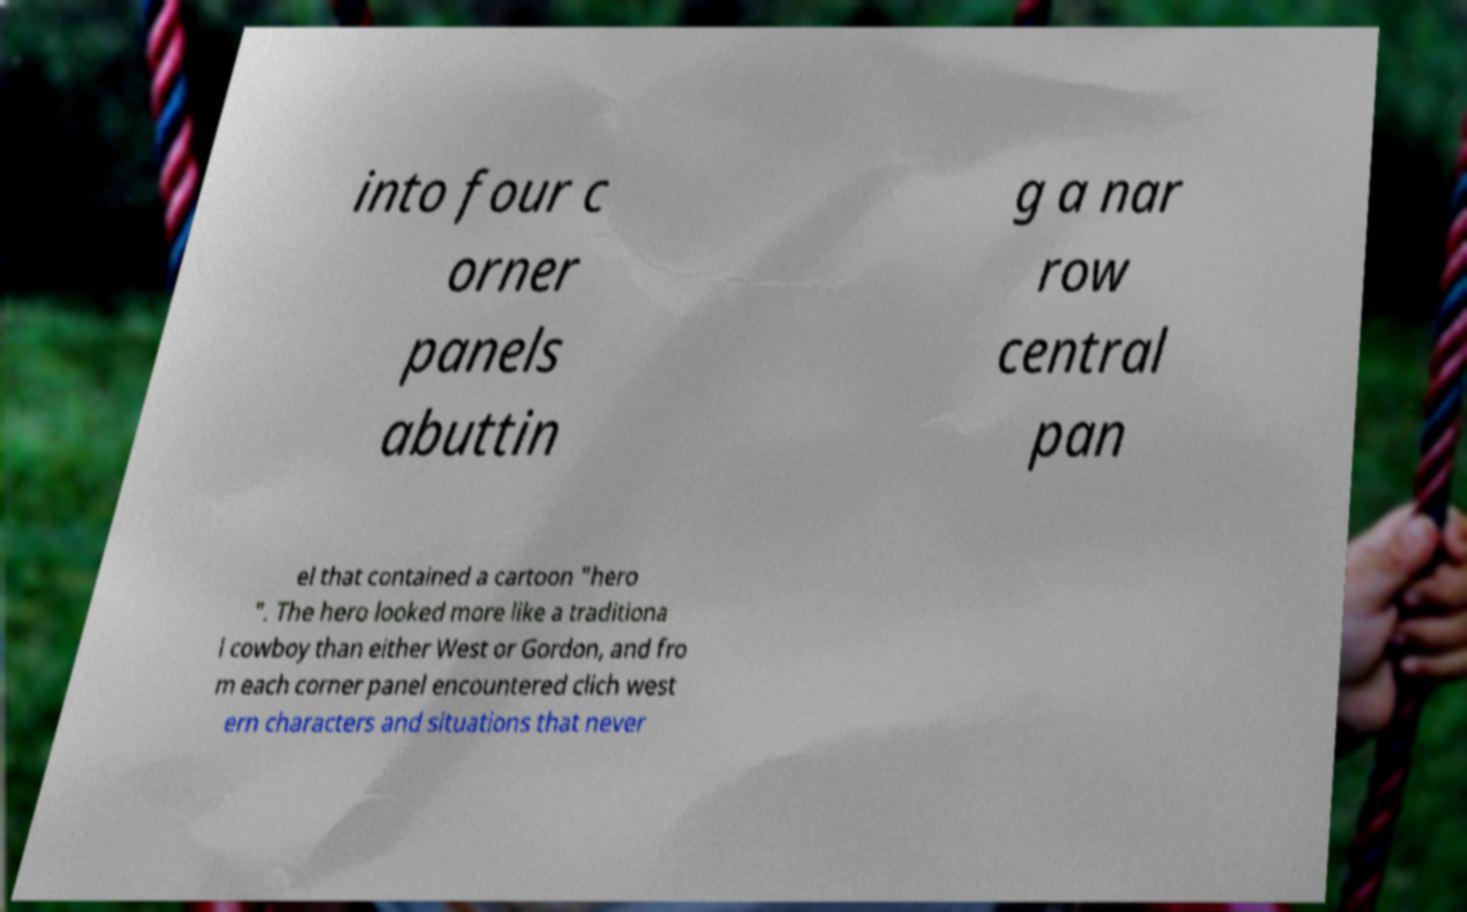Please identify and transcribe the text found in this image. into four c orner panels abuttin g a nar row central pan el that contained a cartoon "hero ". The hero looked more like a traditiona l cowboy than either West or Gordon, and fro m each corner panel encountered clich west ern characters and situations that never 